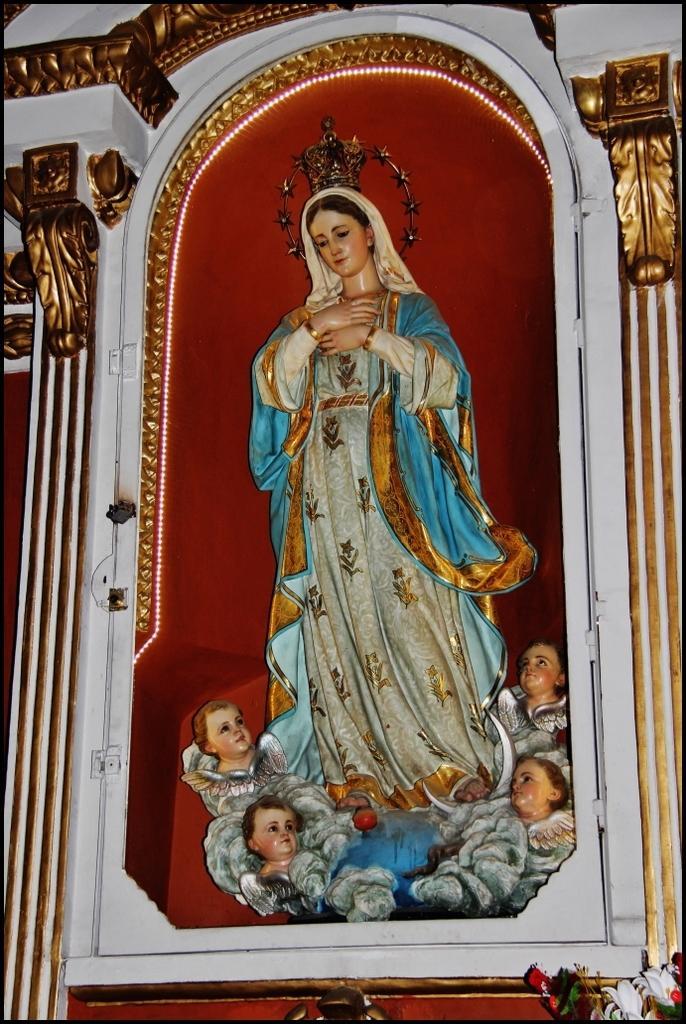How would you summarize this image in a sentence or two? In this image there are sculptures. 